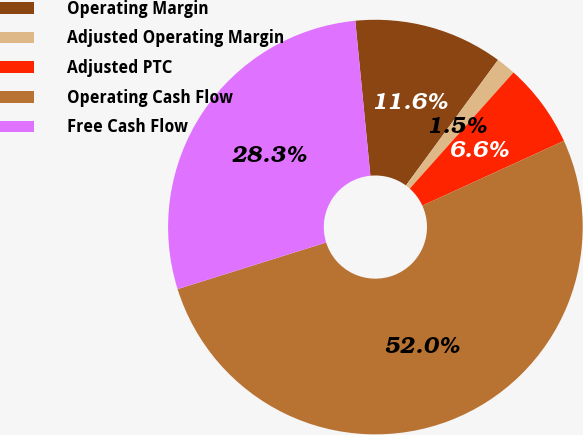Convert chart. <chart><loc_0><loc_0><loc_500><loc_500><pie_chart><fcel>Operating Margin<fcel>Adjusted Operating Margin<fcel>Adjusted PTC<fcel>Operating Cash Flow<fcel>Free Cash Flow<nl><fcel>11.62%<fcel>1.53%<fcel>6.57%<fcel>51.99%<fcel>28.29%<nl></chart> 